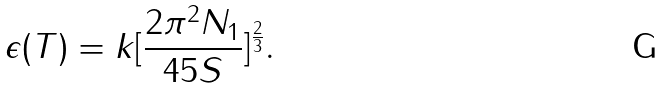<formula> <loc_0><loc_0><loc_500><loc_500>\epsilon ( T ) = k [ \frac { 2 \pi ^ { 2 } N _ { 1 } } { 4 5 S } ] ^ { \frac { 2 } { 3 } } .</formula> 